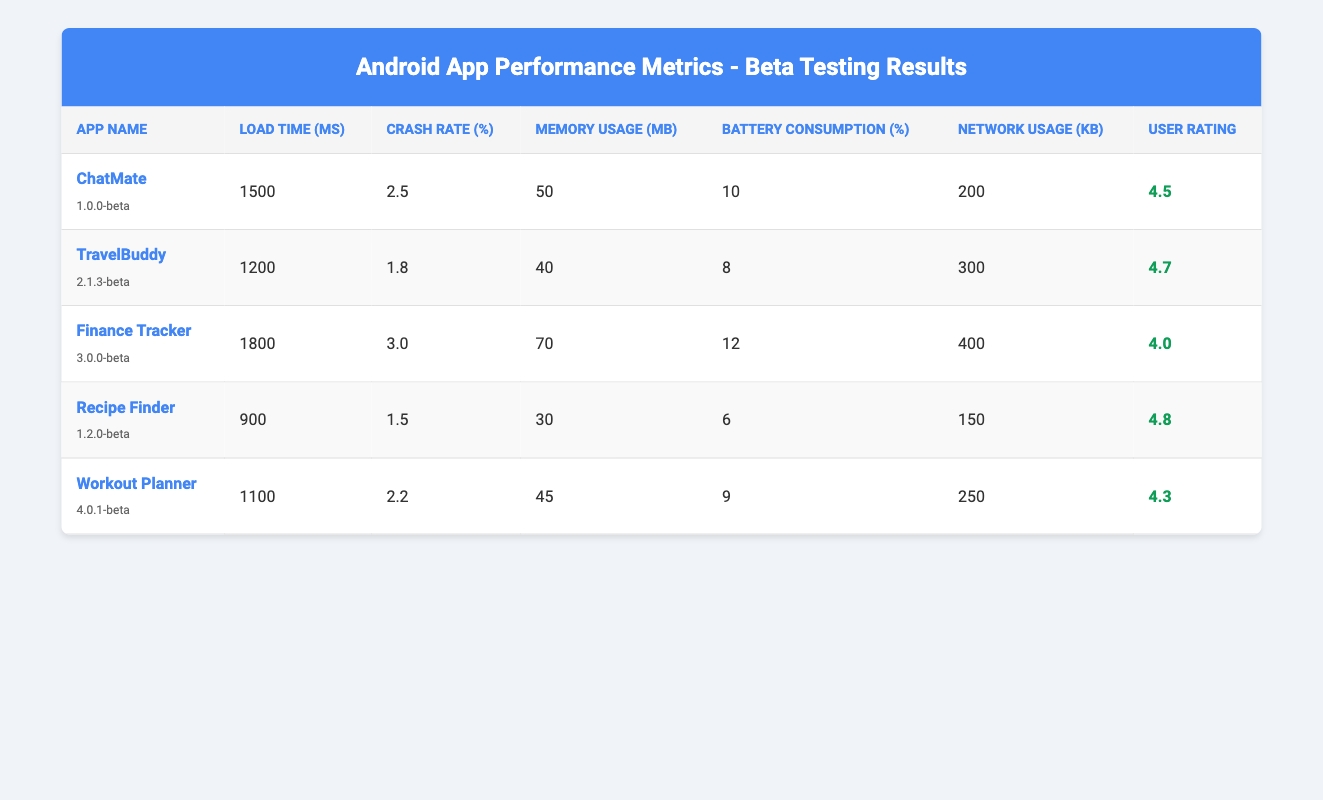What is the load time of TravelBuddy? The table shows that the load time for TravelBuddy is listed under the "Load Time (ms)" column, which states 1200 ms.
Answer: 1200 ms Which app has the highest user rating? By reviewing the "User Rating" column, Recipe Finder has the highest rating of 4.8 among all the apps listed.
Answer: Recipe Finder What is the average battery consumption for all apps? To find the average battery consumption, we sum the battery consumption values: 10 + 8 + 12 + 6 + 9 = 45. Then we divide by the number of apps (5): 45 / 5 = 9.
Answer: 9 Is the crash rate for Finance Tracker less than 2%? The crash rate for Finance Tracker is 3.0%, which is greater than 2%. Thus, the answer is no.
Answer: No Which app has the lowest memory usage? Looking at the "Memory Usage (MB)" column, Recipe Finder shows the least memory usage at 30 MB compared to other apps.
Answer: Recipe Finder What is the difference in load time between Recipe Finder and Workout Planner? The load time for Recipe Finder is 900 ms, and for Workout Planner it is 1100 ms. The difference is calculated as 1100 - 900 = 200 ms.
Answer: 200 ms Is it true that TravelBuddy uses more network resources than ChatMate? Checking the "Network Usage (KB)" column, TravelBuddy uses 300 KB while ChatMate uses 200 KB. Since 300 KB is greater than 200 KB, the statement is true.
Answer: Yes What is the total network usage of all apps combined? Summing the network usage values gives: 200 + 300 + 400 + 150 + 250 = 1300 KB.
Answer: 1300 KB 